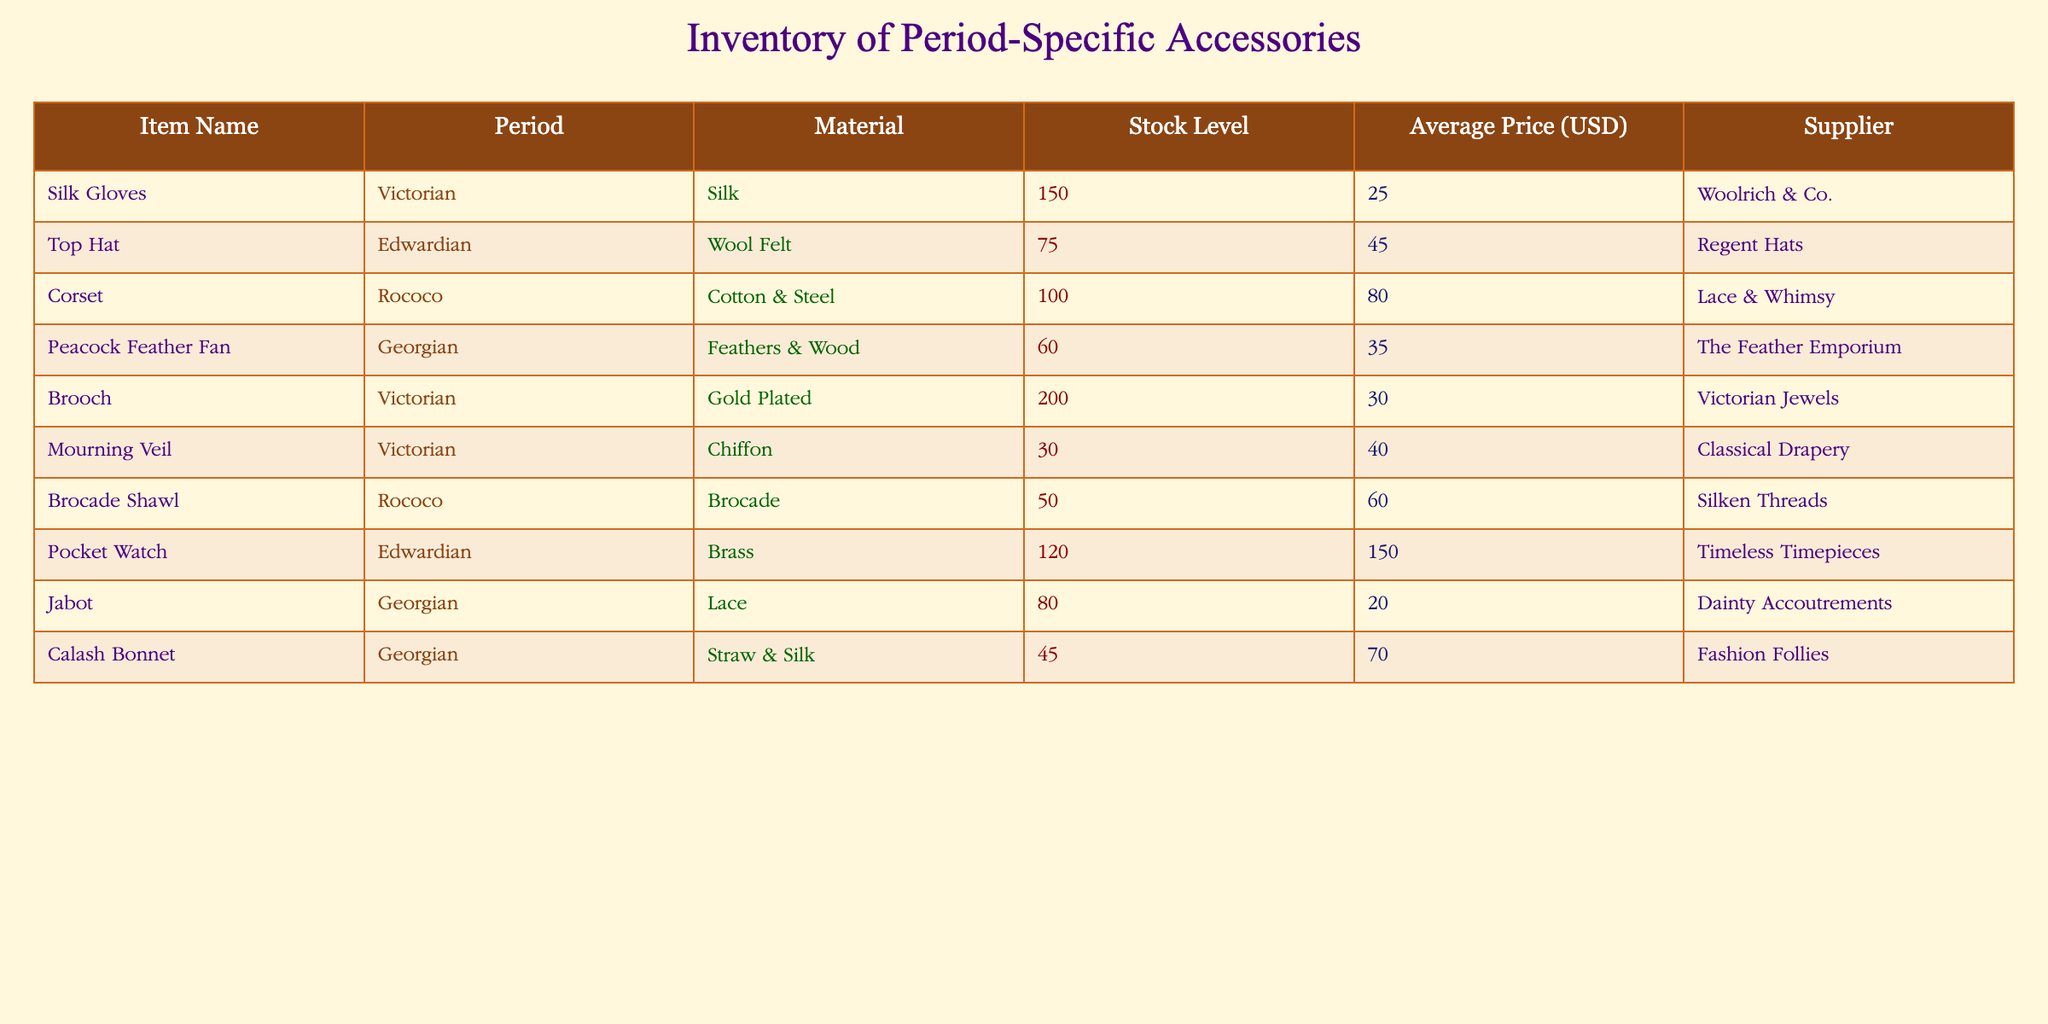What is the stock level of the Silk Gloves? The stock level can be found by locating the row for Silk Gloves and checking the corresponding stock level column. It shows 150.
Answer: 150 Which supplier provides the Top Hat? To answer this question, look for the row that contains the Top Hat and identify the Supplier column to see that it is supplied by Regent Hats.
Answer: Regent Hats How many items in total are available for the Rococo period? To find the total for the Rococo period, add the stock levels of all Rococo items: Corset (100), Brocade Shawl (50). The total is 100 + 50 = 150.
Answer: 150 Is the Mourning Veil stock level greater than 40? Check the stock level for the Mourning Veil in the table; it is 30, which is not greater than 40, making this statement false.
Answer: No Which period has the highest stock level of accessories? Compare the stock levels across all periods: Victorian has 150 (Silk Gloves), 200 (Brooch), and 30 (Mourning Veil), totaling 380. Edwardian has 75 (Top Hat) and 120 (Pocket Watch) totaling 195. Rococo has 100 (Corset) and 50 (Brocade Shawl), totaling 150. Georgian has 60 (Peacock Feather Fan), 80 (Jabot), and 45 (Calash Bonnet), totaling 185. Victorian has the highest total stock level of 380.
Answer: Victorian What is the average price of the Georgian accessories? Identify the items for the Georgian period: Peacock Feather Fan (35), Jabot (20), Calash Bonnet (70). Calculate the average: (35 + 20 + 70) / 3 = 125 / 3 ≈ 41.67.
Answer: 41.67 Which item has the highest average price? Look through the Average Price column and identify the maximum value. The Pocket Watch at 150.00 is the highest.
Answer: Pocket Watch How many items have stock levels of 80 or more? Filter through the stock levels and count the ones equal to or exceeding 80: Silk Gloves (150), Brooch (200), Corset (100), Pocket Watch (120), and Calash Bonnet (45). That gives a total of 4 items.
Answer: 4 Is there an item made of feathers? Look at the Material column for any mention of feathers. The Peacock Feather Fan is identified as made of feathers and wood. Therefore, the answer is true.
Answer: Yes What is the total value of all Victorian period items in stock? Identify the Victorian items: Silk Gloves (150 * 25 = 3750), Brooch (200 * 30 = 6000), Mourning Veil (30 * 40 = 1200). Add the total values: 3750 + 6000 + 1200 = 10950.
Answer: 10950 